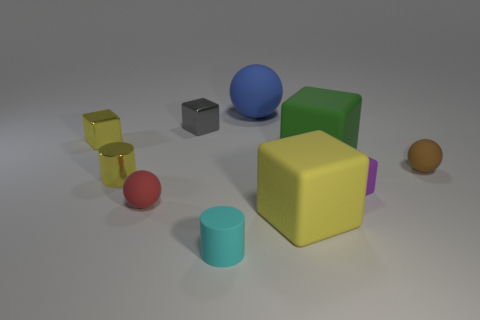Do the cylinder to the right of the small red sphere and the large green thing behind the yellow matte block have the same material? Based on the reflection and texture properties observed, the cylinder to the right of the small red sphere and the large green object in the background both seem to have matte surfaces, suggesting they could be made from the same or similar materials. 